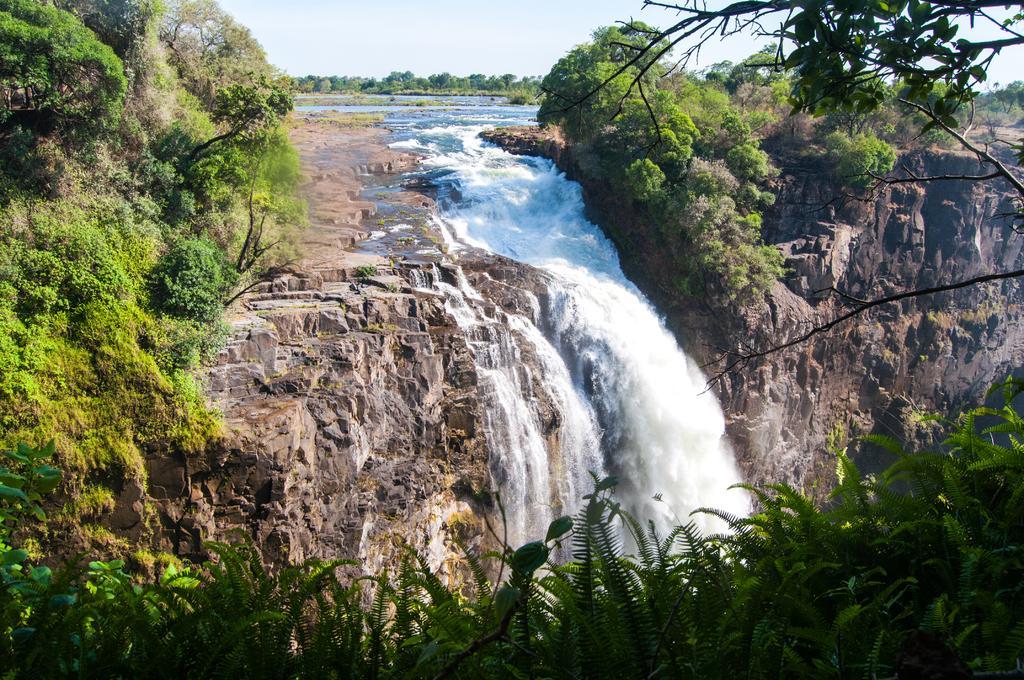How would you summarize this image in a sentence or two? In this picture there is water fall in the center of the image and there is greenery around the area of the image. 